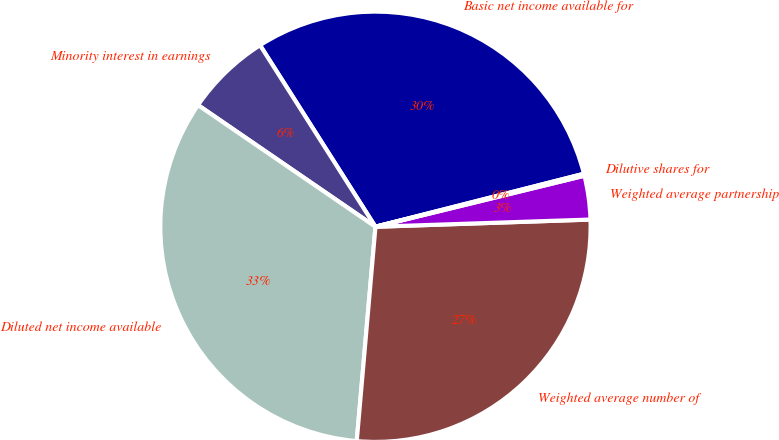Convert chart. <chart><loc_0><loc_0><loc_500><loc_500><pie_chart><fcel>Basic net income available for<fcel>Minority interest in earnings<fcel>Diluted net income available<fcel>Weighted average number of<fcel>Weighted average partnership<fcel>Dilutive shares for<nl><fcel>30.05%<fcel>6.42%<fcel>33.18%<fcel>26.92%<fcel>3.28%<fcel>0.15%<nl></chart> 